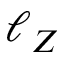<formula> <loc_0><loc_0><loc_500><loc_500>\ell _ { Z }</formula> 